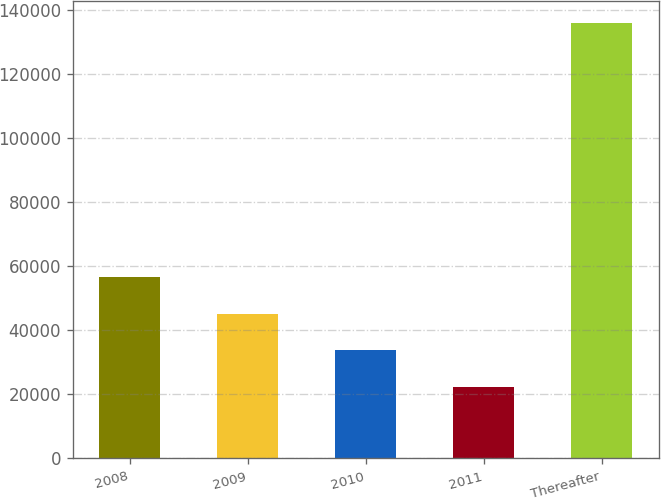Convert chart to OTSL. <chart><loc_0><loc_0><loc_500><loc_500><bar_chart><fcel>2008<fcel>2009<fcel>2010<fcel>2011<fcel>Thereafter<nl><fcel>56473.4<fcel>45112.6<fcel>33751.8<fcel>22391<fcel>135999<nl></chart> 